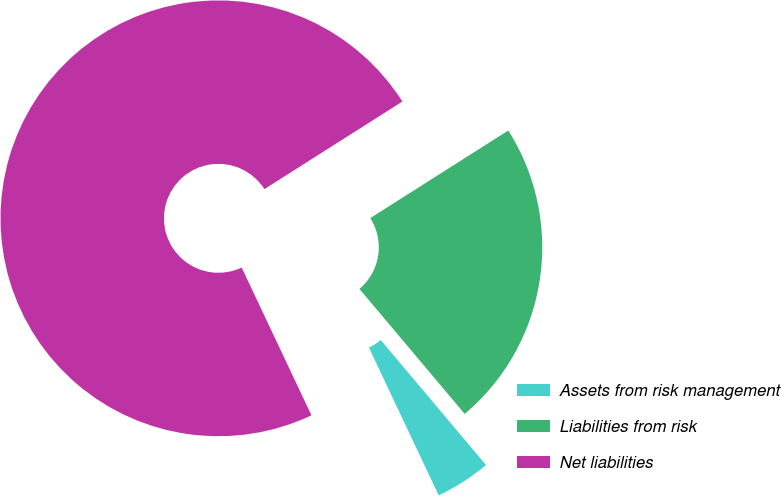<chart> <loc_0><loc_0><loc_500><loc_500><pie_chart><fcel>Assets from risk management<fcel>Liabilities from risk<fcel>Net liabilities<nl><fcel>4.12%<fcel>22.86%<fcel>73.02%<nl></chart> 